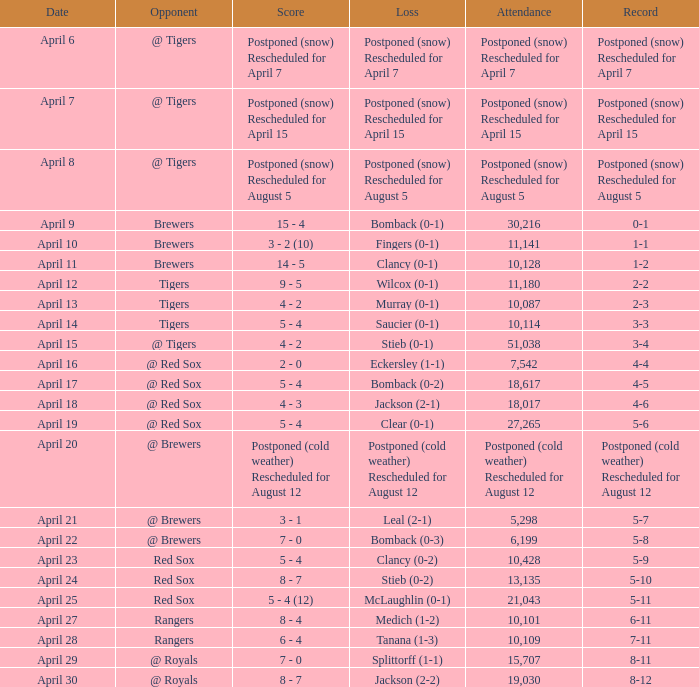What was the date of the match that had a turnout of 10,101? April 27. 